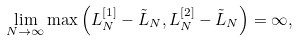Convert formula to latex. <formula><loc_0><loc_0><loc_500><loc_500>\lim _ { N \to \infty } \max \left ( L ^ { [ 1 ] } _ { N } - \tilde { L } _ { N } , L ^ { [ 2 ] } _ { N } - \tilde { L } _ { N } \right ) = \infty ,</formula> 